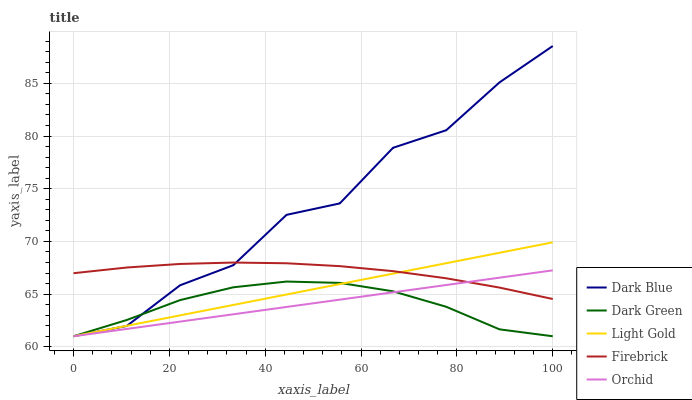Does Dark Green have the minimum area under the curve?
Answer yes or no. Yes. Does Dark Blue have the maximum area under the curve?
Answer yes or no. Yes. Does Firebrick have the minimum area under the curve?
Answer yes or no. No. Does Firebrick have the maximum area under the curve?
Answer yes or no. No. Is Light Gold the smoothest?
Answer yes or no. Yes. Is Dark Blue the roughest?
Answer yes or no. Yes. Is Firebrick the smoothest?
Answer yes or no. No. Is Firebrick the roughest?
Answer yes or no. No. Does Dark Blue have the lowest value?
Answer yes or no. Yes. Does Firebrick have the lowest value?
Answer yes or no. No. Does Dark Blue have the highest value?
Answer yes or no. Yes. Does Firebrick have the highest value?
Answer yes or no. No. Is Dark Green less than Firebrick?
Answer yes or no. Yes. Is Firebrick greater than Dark Green?
Answer yes or no. Yes. Does Dark Blue intersect Dark Green?
Answer yes or no. Yes. Is Dark Blue less than Dark Green?
Answer yes or no. No. Is Dark Blue greater than Dark Green?
Answer yes or no. No. Does Dark Green intersect Firebrick?
Answer yes or no. No. 